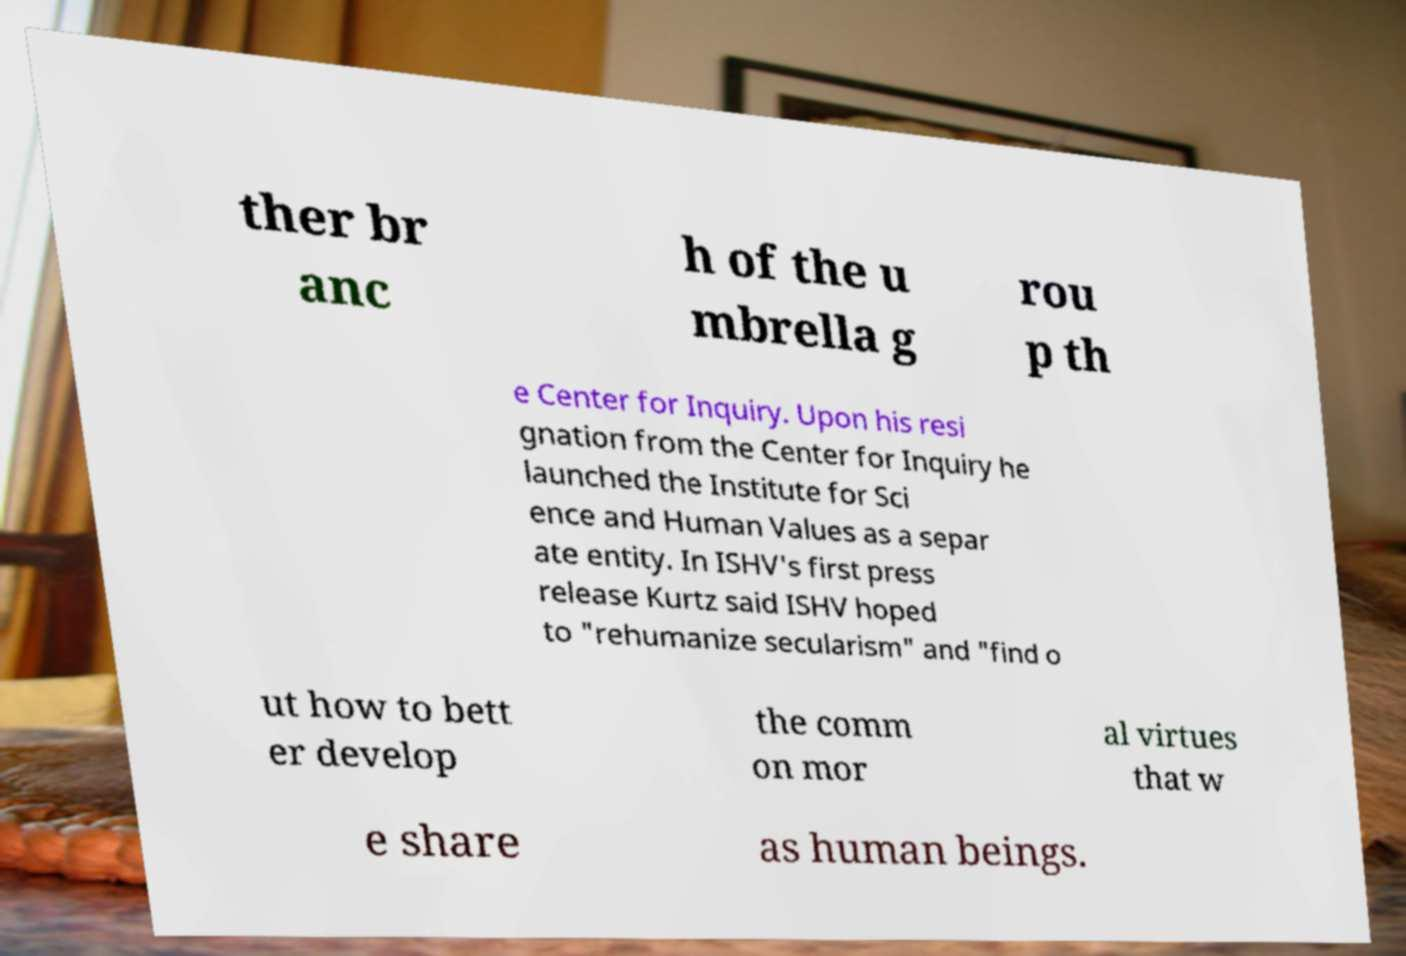For documentation purposes, I need the text within this image transcribed. Could you provide that? ther br anc h of the u mbrella g rou p th e Center for Inquiry. Upon his resi gnation from the Center for Inquiry he launched the Institute for Sci ence and Human Values as a separ ate entity. In ISHV's first press release Kurtz said ISHV hoped to "rehumanize secularism" and "find o ut how to bett er develop the comm on mor al virtues that w e share as human beings. 